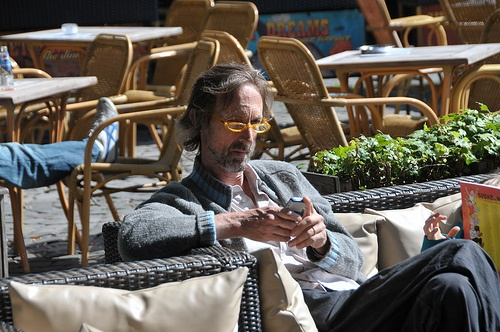Describe the objects in this image and their specific colors. I can see people in black, gray, darkgray, and lightgray tones, couch in black, darkgray, lightgray, and gray tones, chair in black, maroon, and darkgray tones, couch in black, lightgray, gray, and darkgray tones, and chair in black, maroon, and gray tones in this image. 